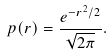Convert formula to latex. <formula><loc_0><loc_0><loc_500><loc_500>p ( r ) = \frac { e ^ { - r ^ { 2 } / 2 } } { \sqrt { 2 \pi } } .</formula> 